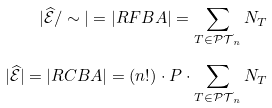Convert formula to latex. <formula><loc_0><loc_0><loc_500><loc_500>| \widehat { \mathcal { E } } / \sim | = | R F B A | = \sum _ { T \in \mathcal { P T } _ { n } } N _ { T } \\ | \widehat { \mathcal { E } } | = | R C B A | = ( n ! ) \cdot P \cdot \sum _ { T \in \mathcal { P T } _ { n } } N _ { T }</formula> 